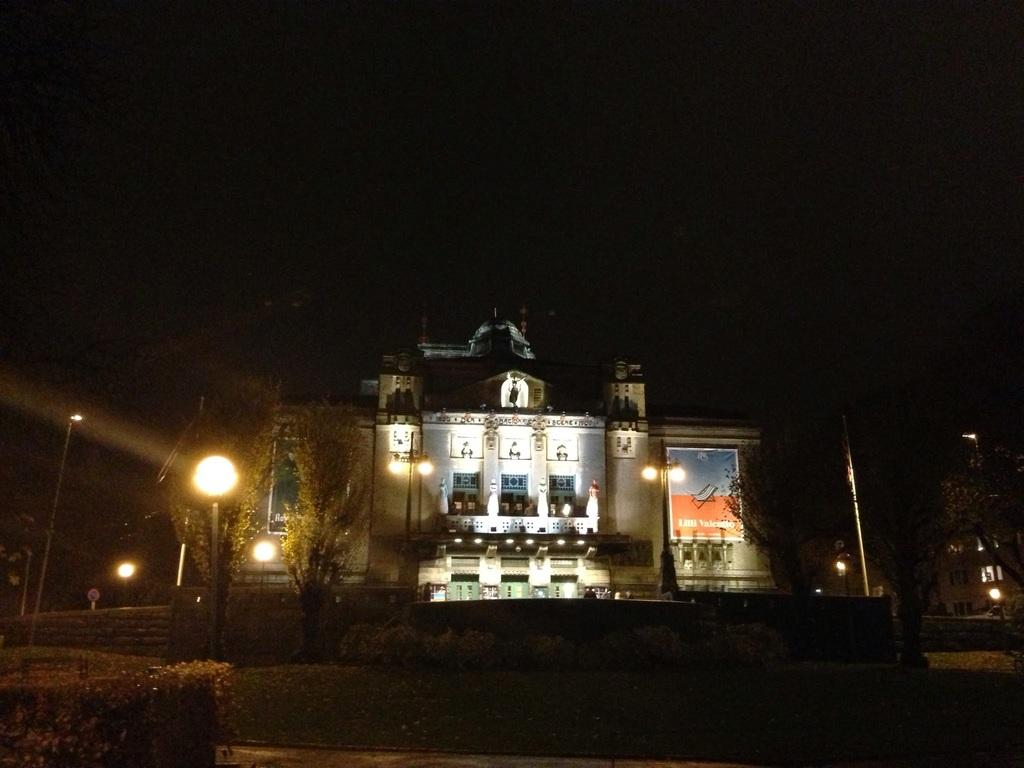Where was the image taken? The image was taken outside. What can be seen in the middle of the image? There are trees and a building in the middle of the image. What is the appearance of the building? The building has windows. What else can be seen in the image? There are lights visible in the image. What type of vegetation is at the bottom of the image? There are bushes at the bottom of the image. What type of ball is being used by the passenger in the image? There is no ball or passenger present in the image. 